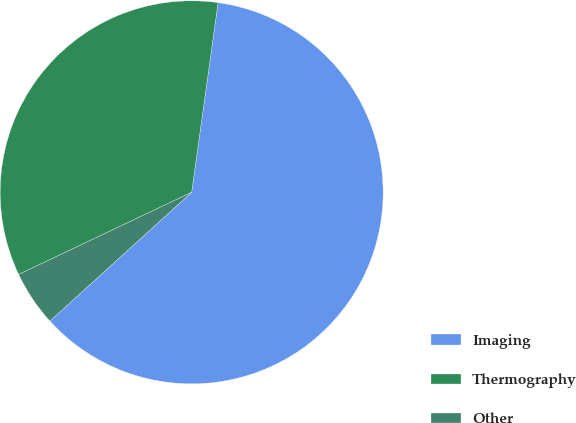<chart> <loc_0><loc_0><loc_500><loc_500><pie_chart><fcel>Imaging<fcel>Thermography<fcel>Other<nl><fcel>61.06%<fcel>34.26%<fcel>4.68%<nl></chart> 